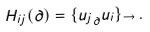<formula> <loc_0><loc_0><loc_500><loc_500>H _ { i j } ( \partial ) = \{ { u _ { j } } _ { \partial } u _ { i } \} _ { \to } \, .</formula> 